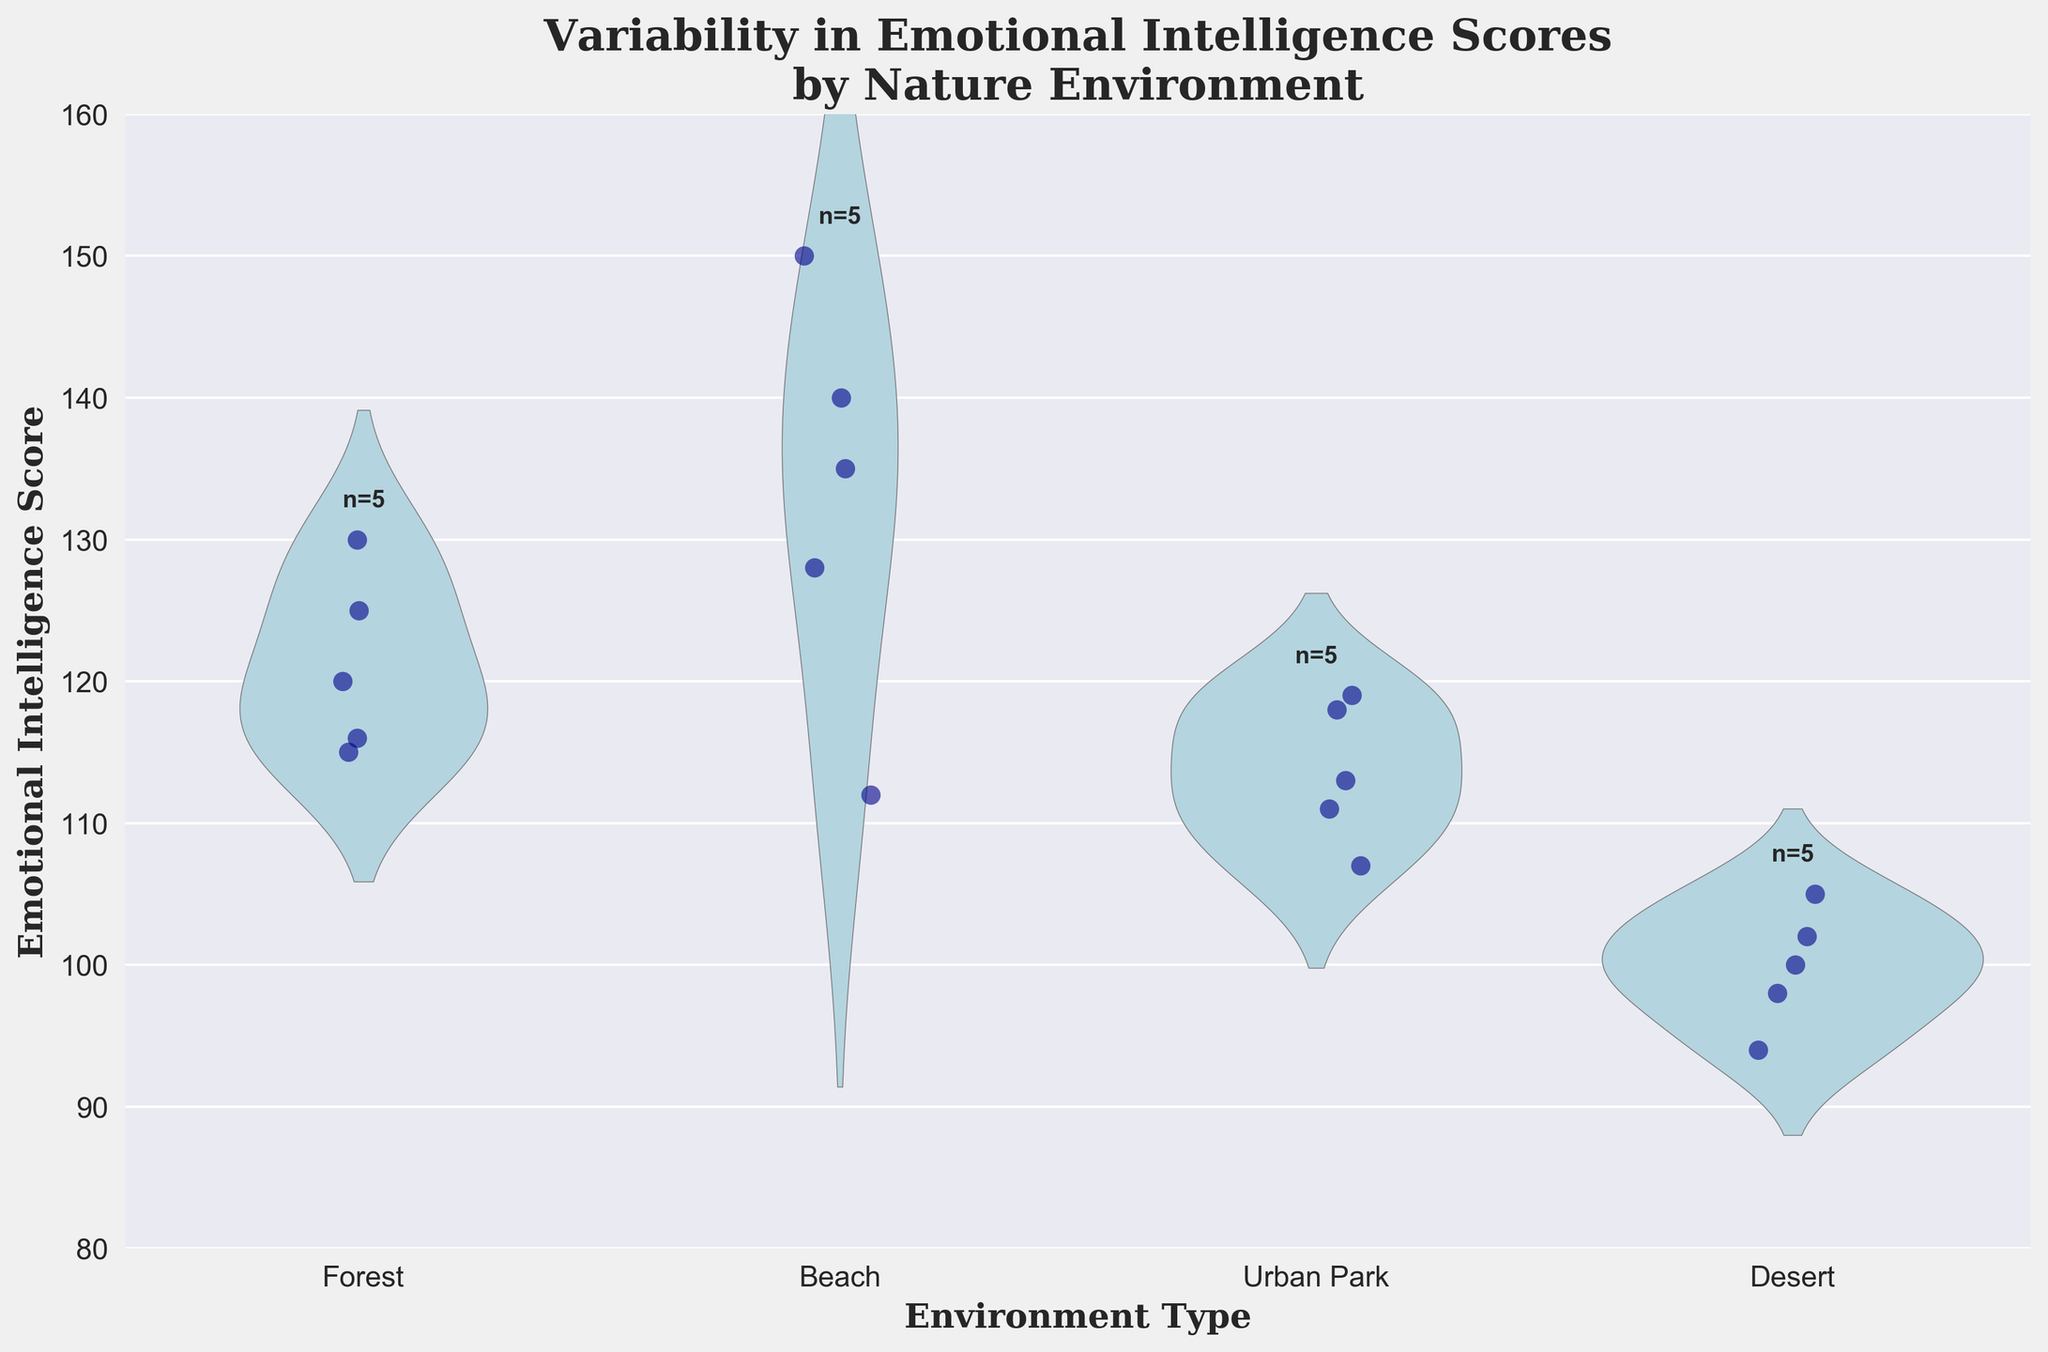What's the title of the figure? The title of the figure is located at the top and reads "Variability in Emotional Intelligence Scores by Nature Environment".
Answer: Variability in Emotional Intelligence Scores by Nature Environment What are the types of environments compared in the figure? The x-axis shows the different environments being compared, which are Forest, Beach, Urban Park, and Desert.
Answer: Forest, Beach, Urban Park, Desert Which environment has the highest maximum Emotional Intelligence score? By looking at the topmost points in each environment's violin plot, the Beach environment has the highest maximum score.
Answer: Beach How many participants were assessed in the Forest environment? The figure has a text annotation above each environment's violin plot indicating the number of participants, and for the Forest, it states "n=5".
Answer: 5 Which environment has the most diverse range of Emotional Intelligence scores? By evaluating the width and spread of the violin plots, the Desert environment has the thinnest spread, indicating the least diversity, whereas the Beach environment shows the widest and most varied range.
Answer: Beach What is the approximate median Emotional Intelligence score for participants in the Urban Park environment? The median can be inferred from the thickest part of the violin plot for the Urban Park environment, which occurs around the central value, approximately at 115.
Answer: 115 Compare the Emotional Intelligence scores in Beach and Desert environments. Which one shows higher scores on average? The average scores can be inferred by looking at the central parts of the violin plots: the Beach environment has higher central values compared to the Desert environment.
Answer: Beach What is the lowest recorded Emotional Intelligence score and in which environment? By identifying the lowest point in the entire figure, the lowest score is around 94 in the Desert environment.
Answer: 94, Desert Is the range of Emotional Intelligence scores in the Forest environment more or less concentrated than the Beach environment? The range in the Forest is less concentrated as it has a wider violin spread, whereas the Beach has a more varied but visually broader range.
Answer: Less concentrated How many environments have a max Emotional Intelligence score above 130? By looking at the top of each violin plot, the environments with max scores above 130 are Forest, Beach, and Urban Park, making it three environments.
Answer: 3 